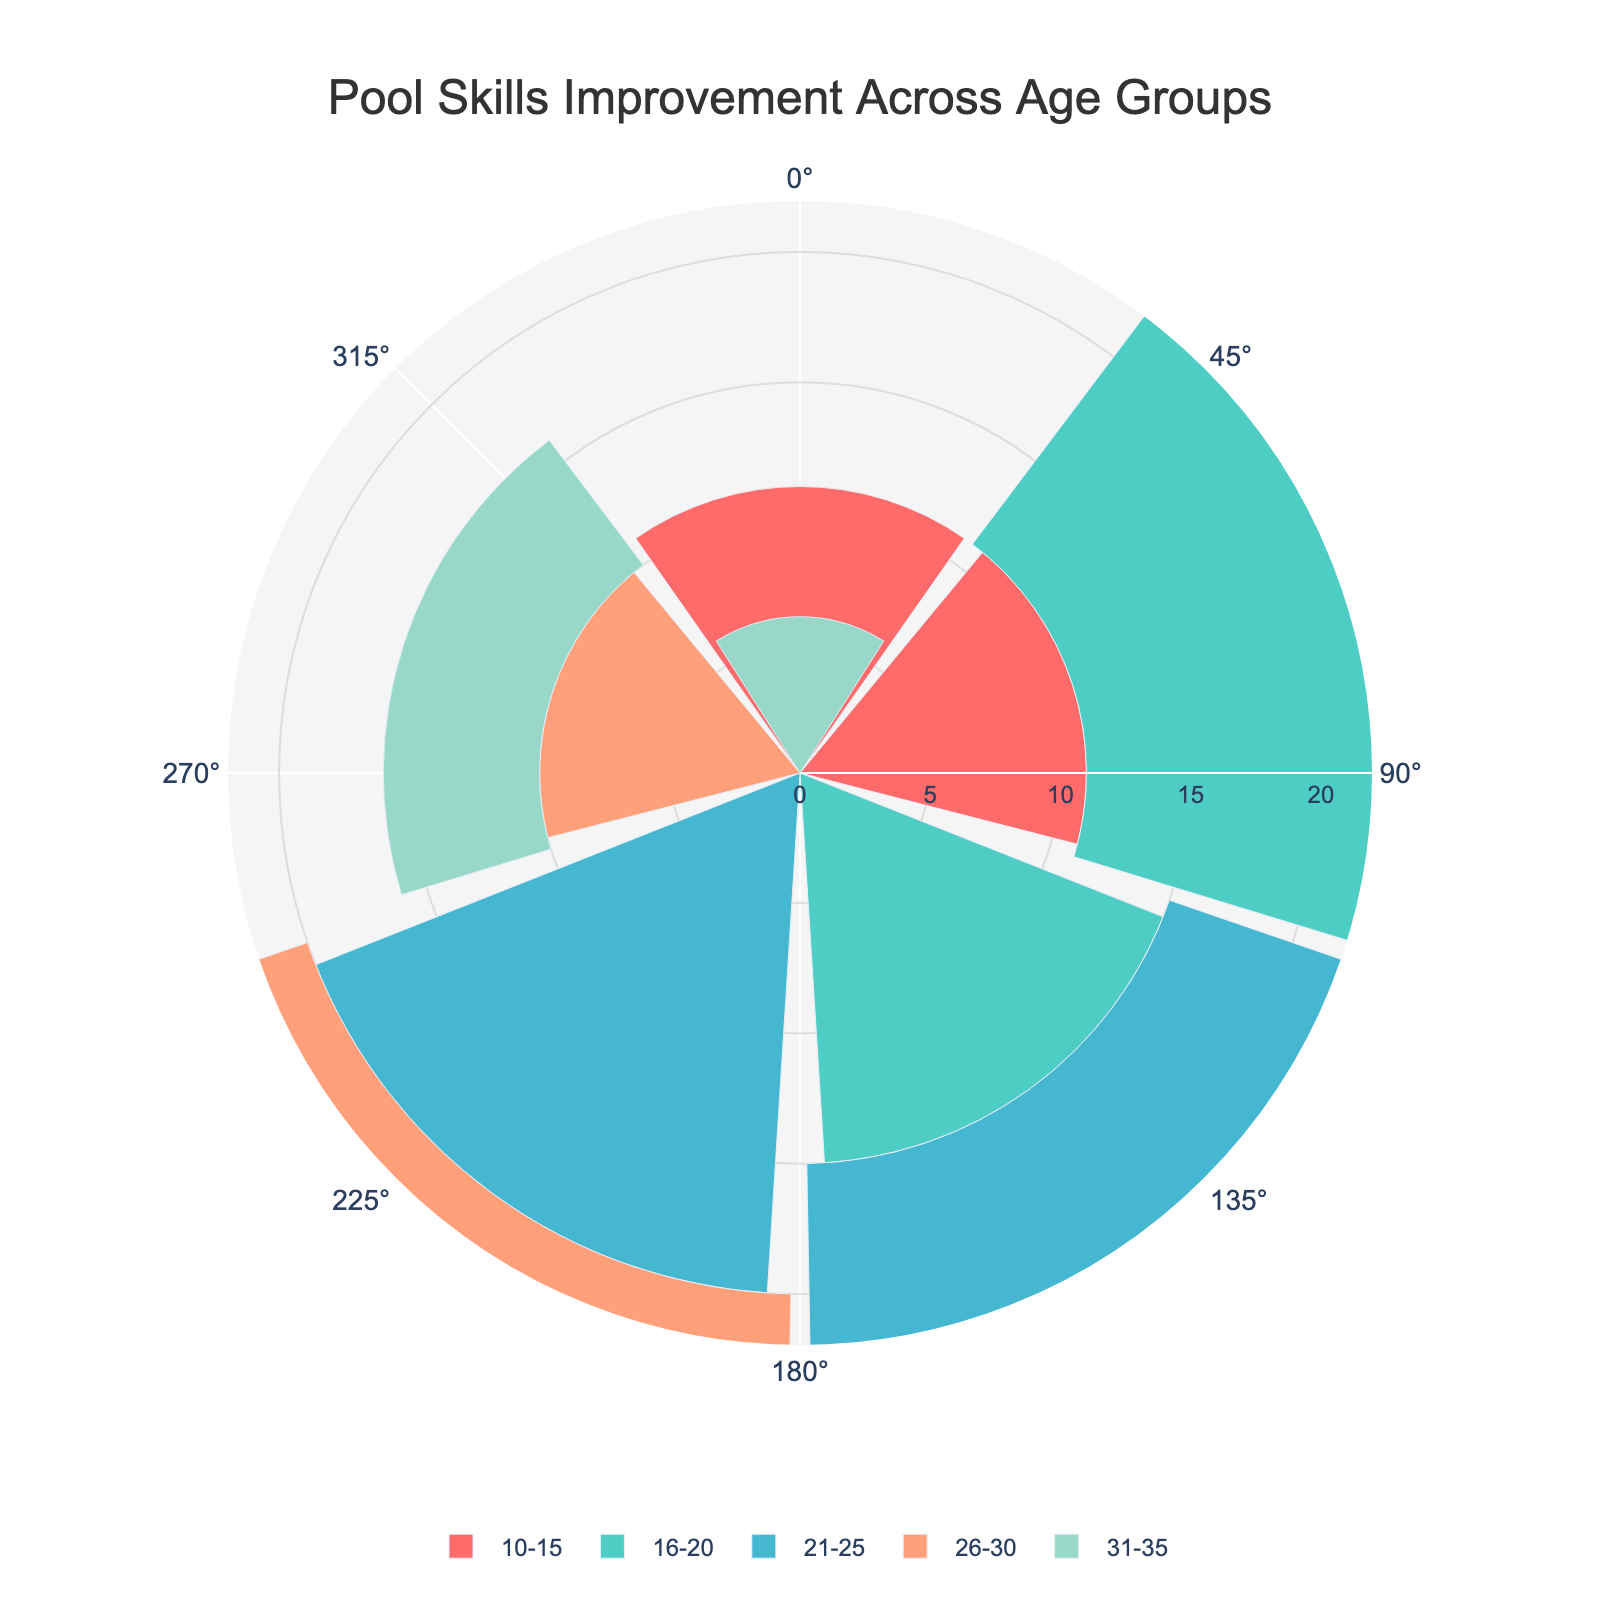What is the title of the figure? The title is typically found at the top of the figure. For this rose chart, it can be seen written clearly, announcing the content of the chart.
Answer: Pool Skills Improvement Across Age Groups Which age group has the highest average improvement score? By looking at the lengths of the radial bars, the age group with the longest bar has the highest average improvement score. The age group "21-25" has the longest bar.
Answer: 21-25 How many participants are in the 16-20 age group? Hovering over or reading the text associated with the "16-20" radial segment shows the number of participants. The text reads "Participants: 60".
Answer: 60 Which age group has the lowest average improvement score? The age group with the shortest radial bar in the rose chart has the lowest average improvement score. This is the "31-35" group.
Answer: 31-35 Compare the average improvement score of the 10-15 age group and the 26-30 age group. Which is higher? By comparing the lengths of the radial bars, the 10-15 age group's bar is longer than that of 26-30, indicating a higher average improvement score.
Answer: 10-15 What is the approximate range of improvement scores displayed in the rose chart? The outermost radial axis tick marks the highest displayed improvement score, whereas the innermost marks the lowest score. The highest score shown is around 22, and the lowest is around 5.
Answer: 5-22 How many different age groups are represented in the chart? By counting the number of distinct radial segments (each marked with its age group), there are five different age groups.
Answer: 5 Which age group has the second-highest average improvement score and what is the value? The age group with the next longest radial bar after the highest one is the 21-25 age group. The second longest bar corresponds to the 16-20 age group.
Answer: 16-20 How does the average improvement score of the 31-35 age group compare to the 10-15 age group? The average improvement score can be compared by visually comparing the heights of their respective radial bars. The 31-35 group has a much shorter bar than the 10-15 group.
Answer: Lower 